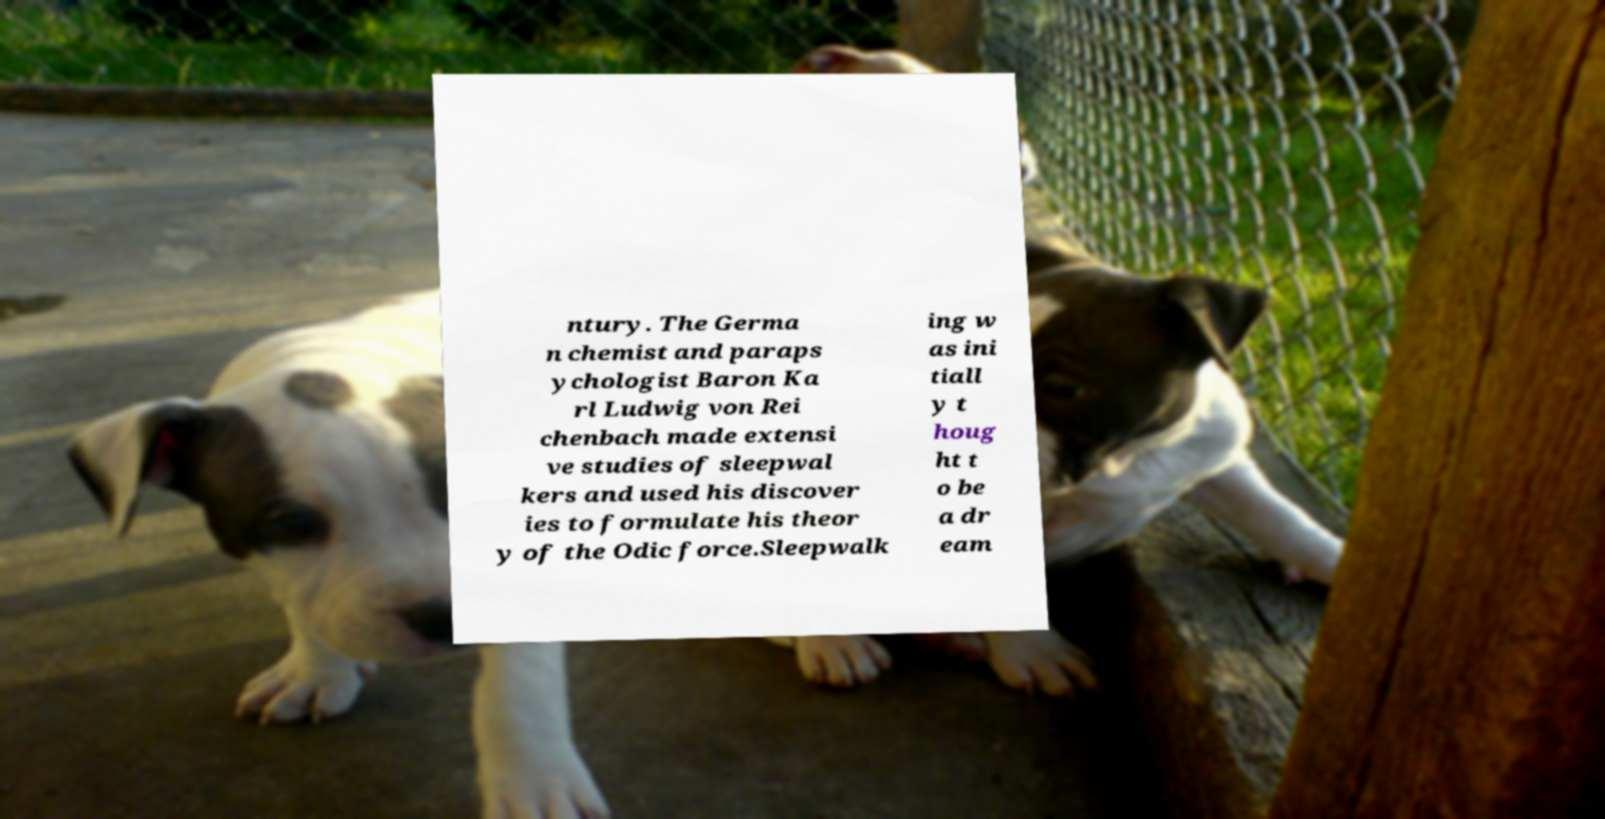Could you extract and type out the text from this image? ntury. The Germa n chemist and paraps ychologist Baron Ka rl Ludwig von Rei chenbach made extensi ve studies of sleepwal kers and used his discover ies to formulate his theor y of the Odic force.Sleepwalk ing w as ini tiall y t houg ht t o be a dr eam 